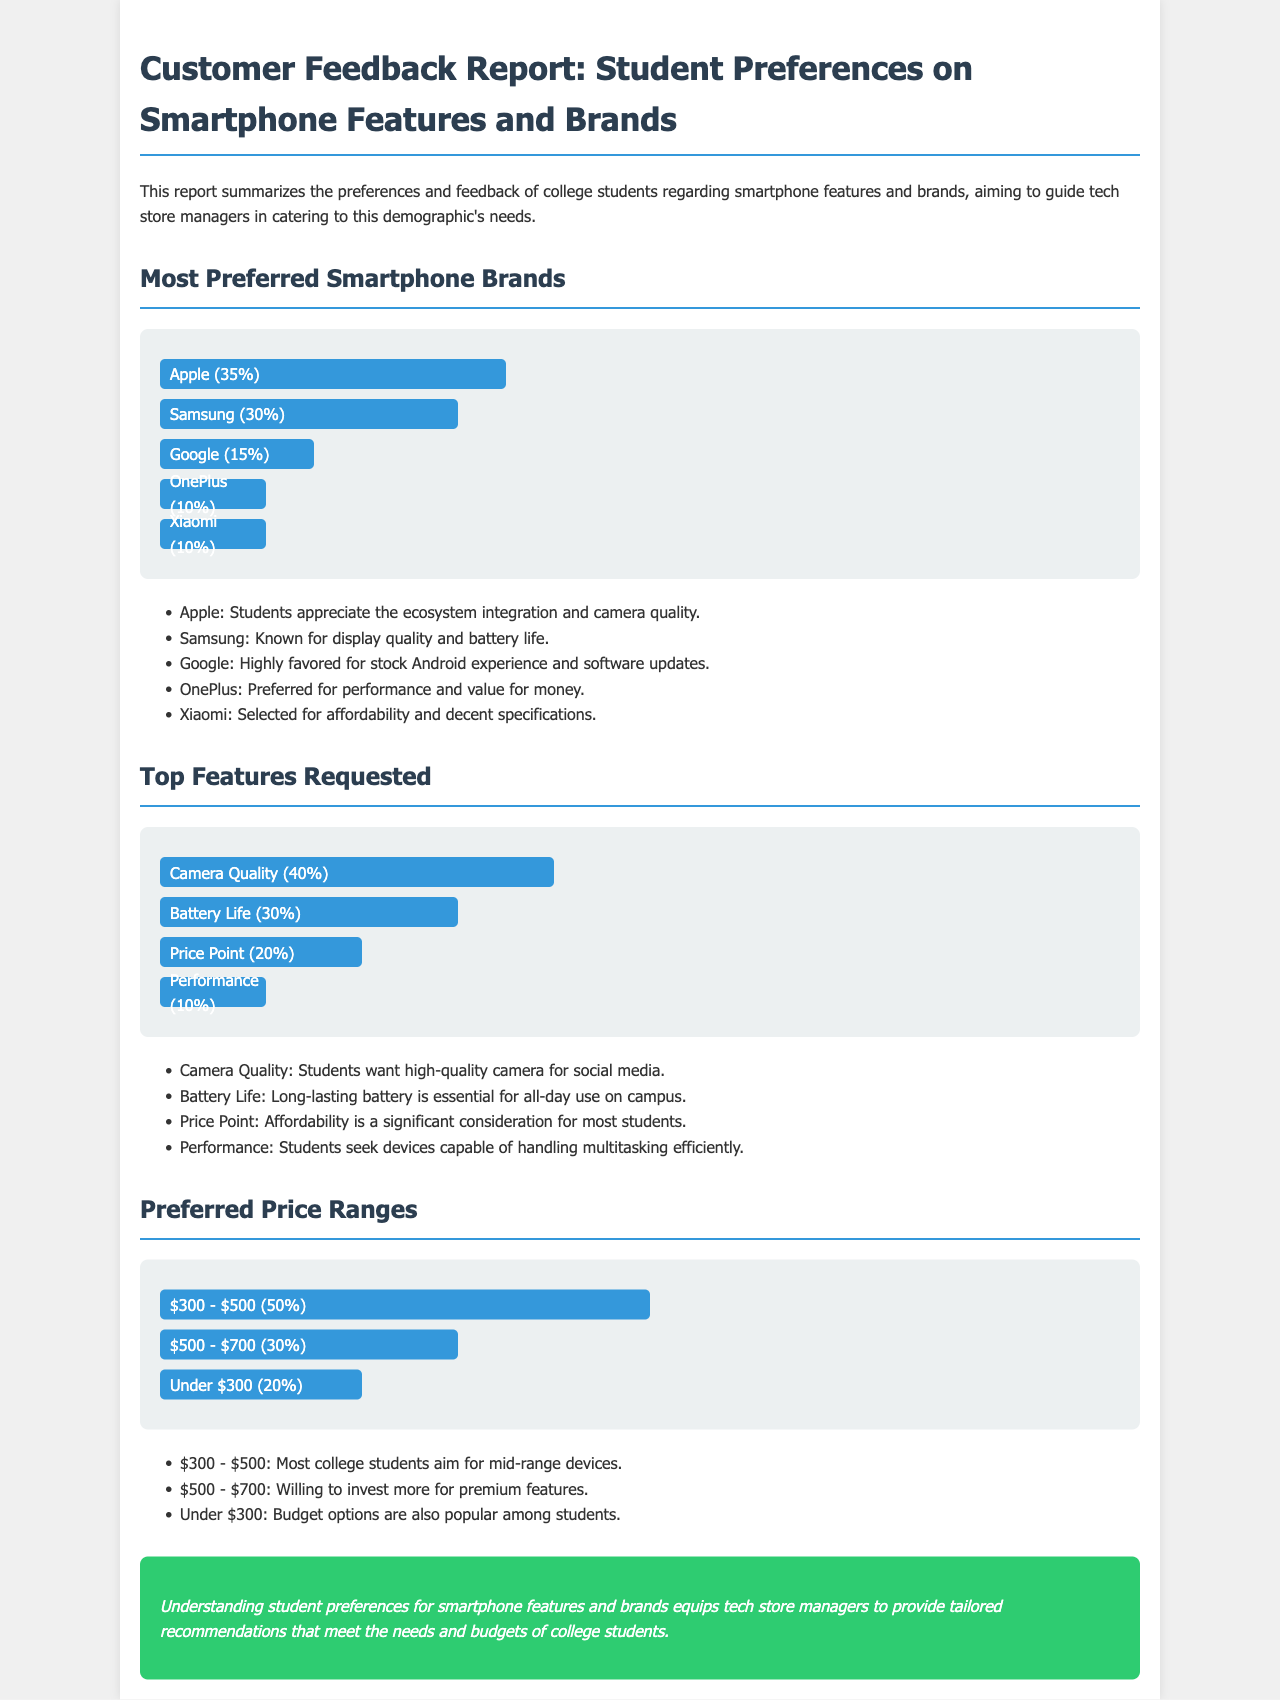What is the most preferred smartphone brand? The most preferred smartphone brand is the one with the highest percentage in the document, which is Apple at 35%.
Answer: Apple What percentage of students prefer Samsung? The percentage of students who prefer Samsung can be found in the document's brand preferences section. It states that Samsung is preferred by 30% of students.
Answer: 30% Which smartphone feature is the most requested? The most requested smartphone feature is identified by the highest percentage in the features section of the document, which is Camera Quality at 40%.
Answer: Camera Quality What is the preferred price range with the highest percentage among students? The preferred price range can be found in the price section of the document, indicating the range with the highest preference, which is $300 - $500 at 50%.
Answer: $300 - $500 Which brand is known for stock Android experience? The brand known for stock Android experience is mentioned in the description of brand preferences, specifically Google.
Answer: Google How many students prefer OnePlus? The preference for OnePlus can be determined from the brand percentages given in the document, stating that 10% of students prefer OnePlus.
Answer: 10% What is the percentage of students concerned with price point? The percentage concerning price point is found in the features section, indicating that 20% of students consider it an important feature.
Answer: 20% Which brand is preferred for affordability? The brand preferred for affordability is mentioned as Xiaomi in the brand preferences section.
Answer: Xiaomi What percentage of students value battery life? The value placed on battery life is indicated by the percentage in the features section, which states 30% of students prioritize this feature.
Answer: 30% 